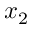<formula> <loc_0><loc_0><loc_500><loc_500>x _ { 2 }</formula> 